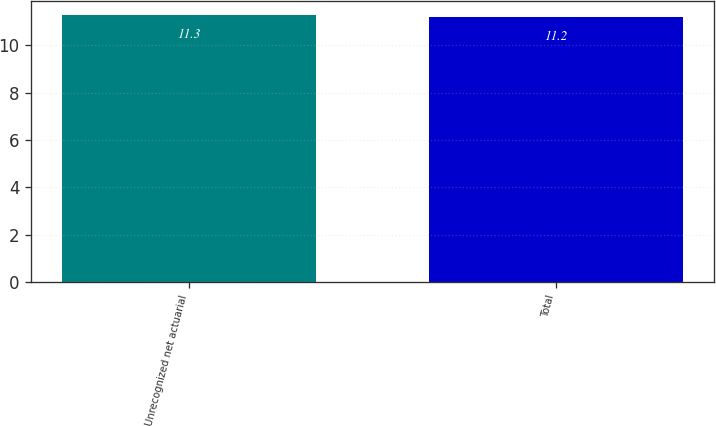Convert chart. <chart><loc_0><loc_0><loc_500><loc_500><bar_chart><fcel>Unrecognized net actuarial<fcel>Total<nl><fcel>11.3<fcel>11.2<nl></chart> 